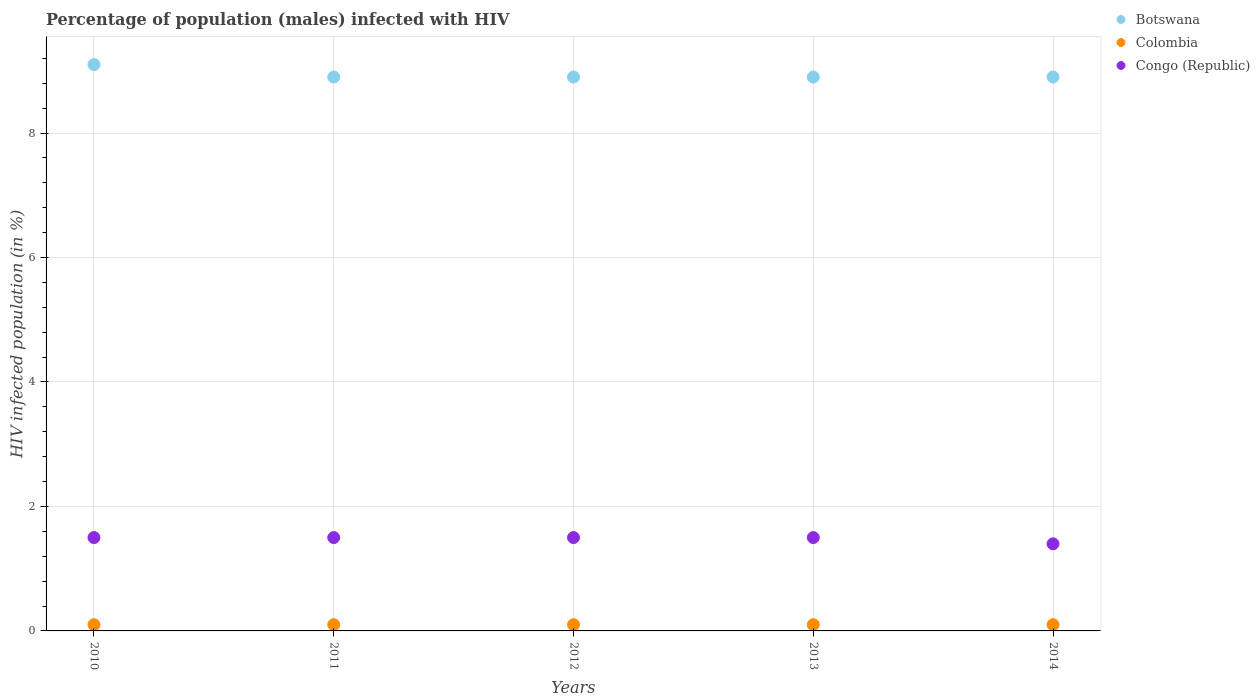How many different coloured dotlines are there?
Give a very brief answer. 3. What is the percentage of HIV infected male population in Colombia in 2010?
Your answer should be very brief. 0.1. In which year was the percentage of HIV infected male population in Congo (Republic) maximum?
Ensure brevity in your answer.  2010. What is the total percentage of HIV infected male population in Congo (Republic) in the graph?
Make the answer very short. 7.4. What is the average percentage of HIV infected male population in Botswana per year?
Offer a terse response. 8.94. In how many years, is the percentage of HIV infected male population in Colombia greater than 2.8 %?
Ensure brevity in your answer.  0. What is the ratio of the percentage of HIV infected male population in Congo (Republic) in 2011 to that in 2013?
Your answer should be compact. 1. What is the difference between the highest and the second highest percentage of HIV infected male population in Congo (Republic)?
Offer a very short reply. 0. What is the difference between the highest and the lowest percentage of HIV infected male population in Congo (Republic)?
Keep it short and to the point. 0.1. Does the percentage of HIV infected male population in Colombia monotonically increase over the years?
Keep it short and to the point. No. Is the percentage of HIV infected male population in Colombia strictly less than the percentage of HIV infected male population in Congo (Republic) over the years?
Provide a succinct answer. Yes. Are the values on the major ticks of Y-axis written in scientific E-notation?
Your response must be concise. No. Does the graph contain grids?
Your response must be concise. Yes. Where does the legend appear in the graph?
Provide a short and direct response. Top right. How many legend labels are there?
Provide a succinct answer. 3. What is the title of the graph?
Give a very brief answer. Percentage of population (males) infected with HIV. Does "Ukraine" appear as one of the legend labels in the graph?
Keep it short and to the point. No. What is the label or title of the Y-axis?
Give a very brief answer. HIV infected population (in %). What is the HIV infected population (in %) in Colombia in 2010?
Offer a very short reply. 0.1. What is the HIV infected population (in %) in Congo (Republic) in 2010?
Provide a succinct answer. 1.5. What is the HIV infected population (in %) of Colombia in 2011?
Offer a very short reply. 0.1. What is the HIV infected population (in %) in Congo (Republic) in 2011?
Offer a very short reply. 1.5. What is the HIV infected population (in %) of Botswana in 2012?
Offer a very short reply. 8.9. What is the HIV infected population (in %) of Colombia in 2012?
Provide a short and direct response. 0.1. What is the HIV infected population (in %) of Congo (Republic) in 2012?
Ensure brevity in your answer.  1.5. What is the HIV infected population (in %) of Botswana in 2013?
Ensure brevity in your answer.  8.9. What is the HIV infected population (in %) in Congo (Republic) in 2013?
Give a very brief answer. 1.5. What is the HIV infected population (in %) of Botswana in 2014?
Provide a succinct answer. 8.9. What is the HIV infected population (in %) of Colombia in 2014?
Your answer should be compact. 0.1. Across all years, what is the maximum HIV infected population (in %) in Congo (Republic)?
Your answer should be very brief. 1.5. Across all years, what is the minimum HIV infected population (in %) of Colombia?
Provide a short and direct response. 0.1. Across all years, what is the minimum HIV infected population (in %) in Congo (Republic)?
Offer a terse response. 1.4. What is the total HIV infected population (in %) in Botswana in the graph?
Your response must be concise. 44.7. What is the total HIV infected population (in %) of Colombia in the graph?
Keep it short and to the point. 0.5. What is the total HIV infected population (in %) in Congo (Republic) in the graph?
Keep it short and to the point. 7.4. What is the difference between the HIV infected population (in %) of Colombia in 2010 and that in 2011?
Offer a terse response. 0. What is the difference between the HIV infected population (in %) of Congo (Republic) in 2010 and that in 2011?
Your response must be concise. 0. What is the difference between the HIV infected population (in %) in Botswana in 2010 and that in 2012?
Your response must be concise. 0.2. What is the difference between the HIV infected population (in %) of Botswana in 2010 and that in 2013?
Make the answer very short. 0.2. What is the difference between the HIV infected population (in %) of Botswana in 2010 and that in 2014?
Your answer should be very brief. 0.2. What is the difference between the HIV infected population (in %) of Botswana in 2011 and that in 2012?
Offer a terse response. 0. What is the difference between the HIV infected population (in %) in Colombia in 2011 and that in 2014?
Provide a short and direct response. 0. What is the difference between the HIV infected population (in %) of Congo (Republic) in 2011 and that in 2014?
Provide a succinct answer. 0.1. What is the difference between the HIV infected population (in %) in Botswana in 2012 and that in 2013?
Your answer should be very brief. 0. What is the difference between the HIV infected population (in %) in Botswana in 2012 and that in 2014?
Provide a short and direct response. 0. What is the difference between the HIV infected population (in %) of Congo (Republic) in 2012 and that in 2014?
Offer a terse response. 0.1. What is the difference between the HIV infected population (in %) in Botswana in 2013 and that in 2014?
Offer a terse response. 0. What is the difference between the HIV infected population (in %) in Botswana in 2010 and the HIV infected population (in %) in Colombia in 2011?
Make the answer very short. 9. What is the difference between the HIV infected population (in %) of Botswana in 2010 and the HIV infected population (in %) of Congo (Republic) in 2012?
Offer a very short reply. 7.6. What is the difference between the HIV infected population (in %) in Botswana in 2010 and the HIV infected population (in %) in Colombia in 2013?
Your answer should be compact. 9. What is the difference between the HIV infected population (in %) in Botswana in 2011 and the HIV infected population (in %) in Colombia in 2012?
Ensure brevity in your answer.  8.8. What is the difference between the HIV infected population (in %) in Botswana in 2011 and the HIV infected population (in %) in Colombia in 2013?
Give a very brief answer. 8.8. What is the difference between the HIV infected population (in %) of Botswana in 2011 and the HIV infected population (in %) of Colombia in 2014?
Give a very brief answer. 8.8. What is the difference between the HIV infected population (in %) of Botswana in 2011 and the HIV infected population (in %) of Congo (Republic) in 2014?
Ensure brevity in your answer.  7.5. What is the difference between the HIV infected population (in %) in Colombia in 2011 and the HIV infected population (in %) in Congo (Republic) in 2014?
Offer a very short reply. -1.3. What is the difference between the HIV infected population (in %) in Botswana in 2012 and the HIV infected population (in %) in Colombia in 2013?
Keep it short and to the point. 8.8. What is the difference between the HIV infected population (in %) of Colombia in 2012 and the HIV infected population (in %) of Congo (Republic) in 2013?
Your answer should be very brief. -1.4. What is the difference between the HIV infected population (in %) in Botswana in 2012 and the HIV infected population (in %) in Colombia in 2014?
Your response must be concise. 8.8. What is the difference between the HIV infected population (in %) in Botswana in 2012 and the HIV infected population (in %) in Congo (Republic) in 2014?
Provide a short and direct response. 7.5. What is the difference between the HIV infected population (in %) in Colombia in 2012 and the HIV infected population (in %) in Congo (Republic) in 2014?
Provide a short and direct response. -1.3. What is the difference between the HIV infected population (in %) of Botswana in 2013 and the HIV infected population (in %) of Colombia in 2014?
Keep it short and to the point. 8.8. What is the difference between the HIV infected population (in %) in Botswana in 2013 and the HIV infected population (in %) in Congo (Republic) in 2014?
Provide a short and direct response. 7.5. What is the difference between the HIV infected population (in %) in Colombia in 2013 and the HIV infected population (in %) in Congo (Republic) in 2014?
Keep it short and to the point. -1.3. What is the average HIV infected population (in %) in Botswana per year?
Offer a very short reply. 8.94. What is the average HIV infected population (in %) in Congo (Republic) per year?
Your answer should be compact. 1.48. In the year 2010, what is the difference between the HIV infected population (in %) in Botswana and HIV infected population (in %) in Congo (Republic)?
Make the answer very short. 7.6. In the year 2011, what is the difference between the HIV infected population (in %) in Botswana and HIV infected population (in %) in Colombia?
Make the answer very short. 8.8. In the year 2011, what is the difference between the HIV infected population (in %) in Botswana and HIV infected population (in %) in Congo (Republic)?
Offer a terse response. 7.4. In the year 2011, what is the difference between the HIV infected population (in %) in Colombia and HIV infected population (in %) in Congo (Republic)?
Ensure brevity in your answer.  -1.4. In the year 2012, what is the difference between the HIV infected population (in %) in Botswana and HIV infected population (in %) in Colombia?
Your answer should be compact. 8.8. In the year 2012, what is the difference between the HIV infected population (in %) in Colombia and HIV infected population (in %) in Congo (Republic)?
Provide a succinct answer. -1.4. In the year 2013, what is the difference between the HIV infected population (in %) of Botswana and HIV infected population (in %) of Congo (Republic)?
Make the answer very short. 7.4. In the year 2013, what is the difference between the HIV infected population (in %) of Colombia and HIV infected population (in %) of Congo (Republic)?
Your answer should be compact. -1.4. In the year 2014, what is the difference between the HIV infected population (in %) in Botswana and HIV infected population (in %) in Congo (Republic)?
Ensure brevity in your answer.  7.5. What is the ratio of the HIV infected population (in %) in Botswana in 2010 to that in 2011?
Offer a very short reply. 1.02. What is the ratio of the HIV infected population (in %) in Colombia in 2010 to that in 2011?
Your answer should be very brief. 1. What is the ratio of the HIV infected population (in %) of Congo (Republic) in 2010 to that in 2011?
Your response must be concise. 1. What is the ratio of the HIV infected population (in %) of Botswana in 2010 to that in 2012?
Your answer should be very brief. 1.02. What is the ratio of the HIV infected population (in %) in Congo (Republic) in 2010 to that in 2012?
Make the answer very short. 1. What is the ratio of the HIV infected population (in %) of Botswana in 2010 to that in 2013?
Give a very brief answer. 1.02. What is the ratio of the HIV infected population (in %) of Colombia in 2010 to that in 2013?
Give a very brief answer. 1. What is the ratio of the HIV infected population (in %) of Congo (Republic) in 2010 to that in 2013?
Make the answer very short. 1. What is the ratio of the HIV infected population (in %) in Botswana in 2010 to that in 2014?
Provide a short and direct response. 1.02. What is the ratio of the HIV infected population (in %) in Congo (Republic) in 2010 to that in 2014?
Make the answer very short. 1.07. What is the ratio of the HIV infected population (in %) in Botswana in 2011 to that in 2012?
Make the answer very short. 1. What is the ratio of the HIV infected population (in %) of Congo (Republic) in 2011 to that in 2012?
Offer a terse response. 1. What is the ratio of the HIV infected population (in %) in Congo (Republic) in 2011 to that in 2013?
Make the answer very short. 1. What is the ratio of the HIV infected population (in %) in Congo (Republic) in 2011 to that in 2014?
Your answer should be compact. 1.07. What is the ratio of the HIV infected population (in %) in Botswana in 2012 to that in 2013?
Your answer should be compact. 1. What is the ratio of the HIV infected population (in %) in Botswana in 2012 to that in 2014?
Your response must be concise. 1. What is the ratio of the HIV infected population (in %) in Colombia in 2012 to that in 2014?
Your answer should be very brief. 1. What is the ratio of the HIV infected population (in %) of Congo (Republic) in 2012 to that in 2014?
Give a very brief answer. 1.07. What is the ratio of the HIV infected population (in %) in Congo (Republic) in 2013 to that in 2014?
Your answer should be very brief. 1.07. What is the difference between the highest and the second highest HIV infected population (in %) in Congo (Republic)?
Provide a short and direct response. 0. What is the difference between the highest and the lowest HIV infected population (in %) of Colombia?
Offer a terse response. 0. What is the difference between the highest and the lowest HIV infected population (in %) of Congo (Republic)?
Offer a very short reply. 0.1. 